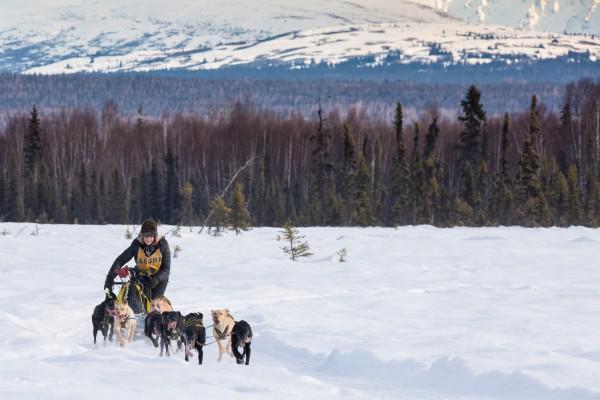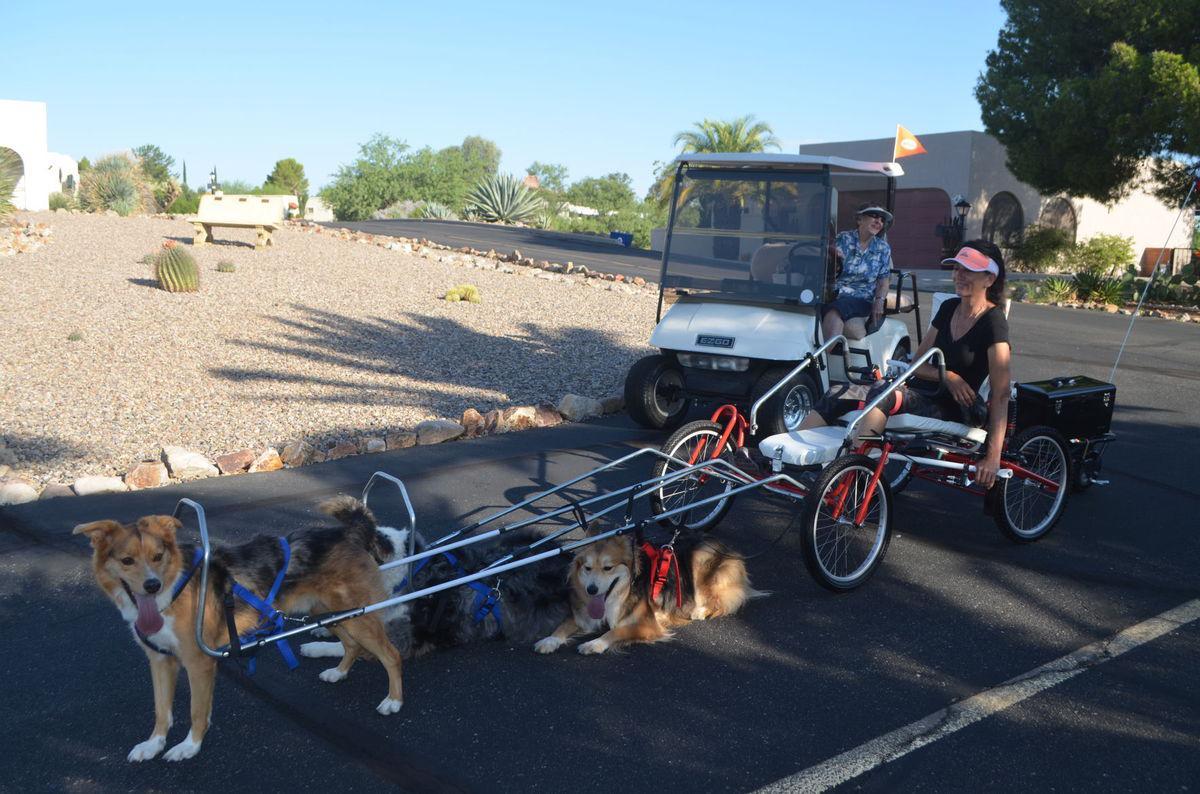The first image is the image on the left, the second image is the image on the right. Given the left and right images, does the statement "The image on the left shows a dog team running in snow." hold true? Answer yes or no. Yes. 